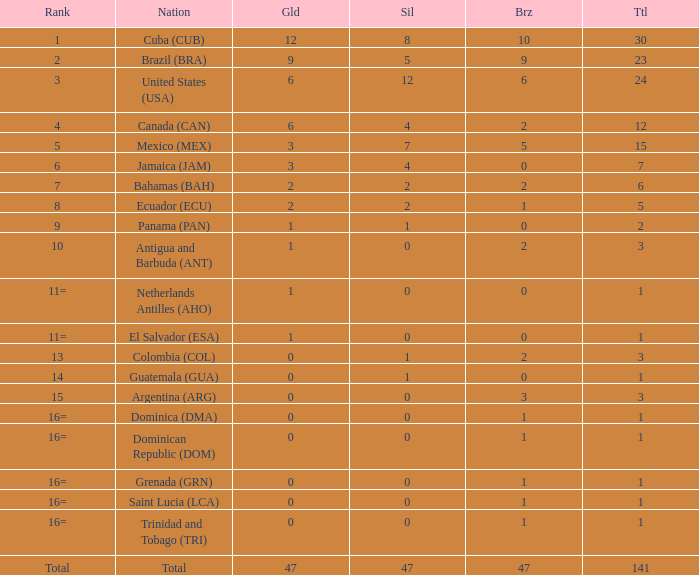What is the average silver with more than 0 gold, a Rank of 1, and a Total smaller than 30? None. 